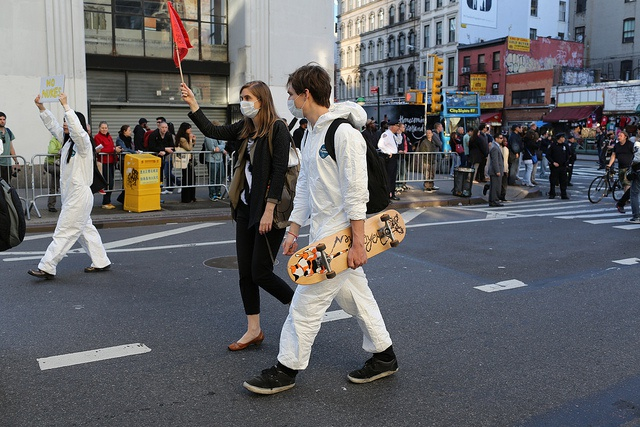Describe the objects in this image and their specific colors. I can see people in darkgray, lightgray, black, and gray tones, people in darkgray, black, gray, maroon, and blue tones, people in darkgray, black, gray, and maroon tones, people in darkgray, lightgray, gray, and black tones, and skateboard in darkgray, tan, and black tones in this image. 